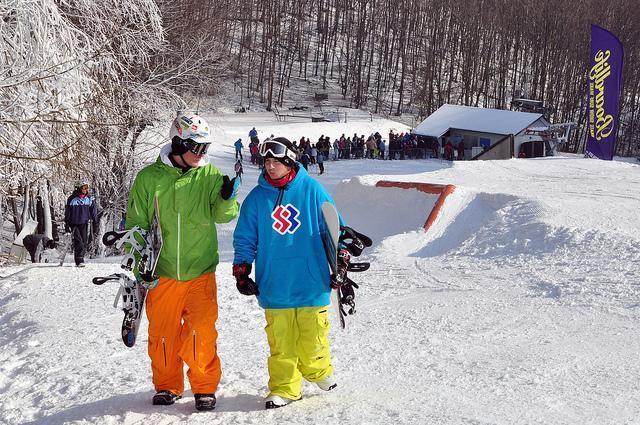How many people are in the picture?
Give a very brief answer. 3. How many giraffe are standing next to each other?
Give a very brief answer. 0. 